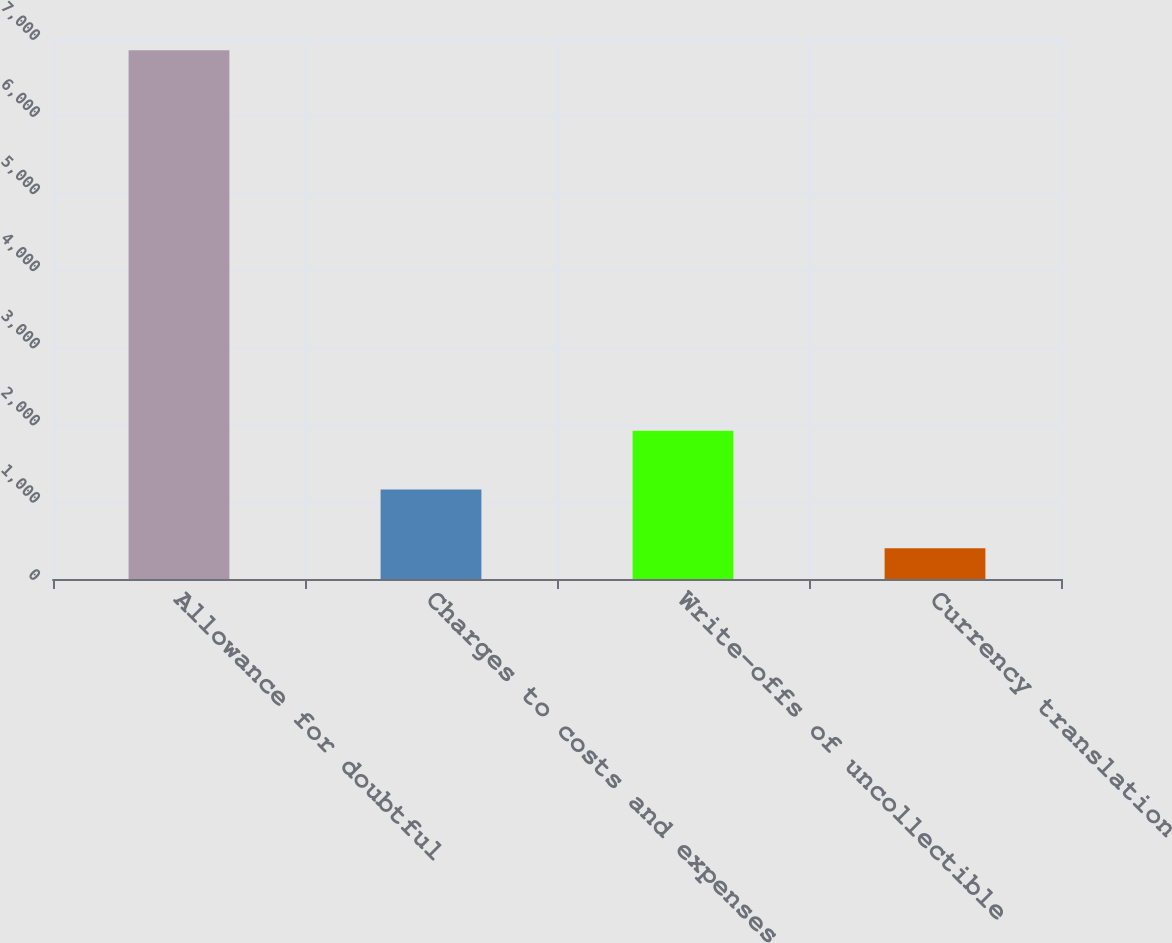Convert chart. <chart><loc_0><loc_0><loc_500><loc_500><bar_chart><fcel>Allowance for doubtful<fcel>Charges to costs and expenses<fcel>Write-offs of uncollectible<fcel>Currency translation<nl><fcel>6853<fcel>1161.4<fcel>1922.8<fcel>400<nl></chart> 